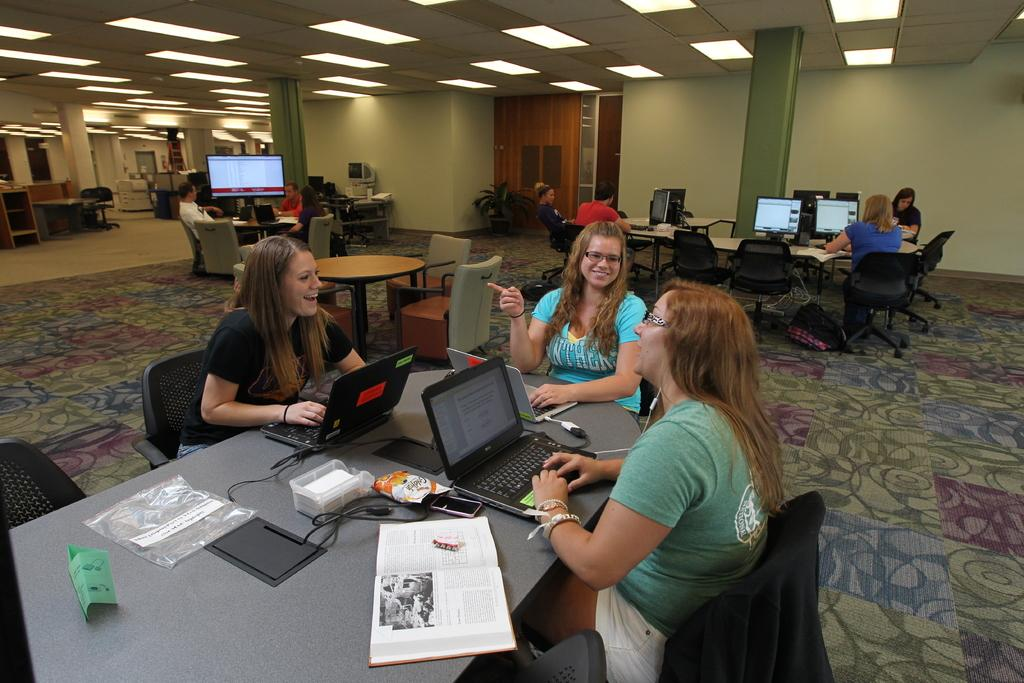What are the people in the image doing? The people in the image are sitting around a table. What objects can be seen on the table? There are laptops, books, and mobile phones on the table. What type of birds can be seen flying around the table in the image? There are no birds visible in the image; it only shows people sitting around a table with laptops, books, and mobile phones. 